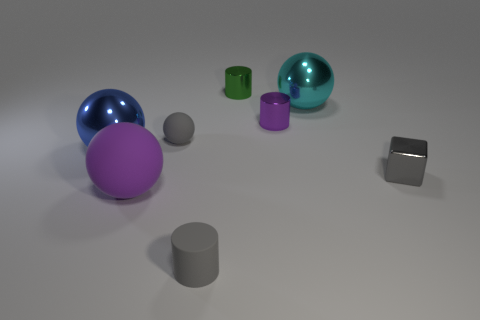Subtract all gray matte cylinders. How many cylinders are left? 2 Add 2 big metal cubes. How many objects exist? 10 Subtract all gray cylinders. How many cylinders are left? 2 Subtract all cubes. How many objects are left? 7 Add 4 big blue objects. How many big blue objects exist? 5 Subtract 0 yellow balls. How many objects are left? 8 Subtract 1 cylinders. How many cylinders are left? 2 Subtract all red cylinders. Subtract all yellow blocks. How many cylinders are left? 3 Subtract all green cubes. How many cyan balls are left? 1 Subtract all purple objects. Subtract all big purple cylinders. How many objects are left? 6 